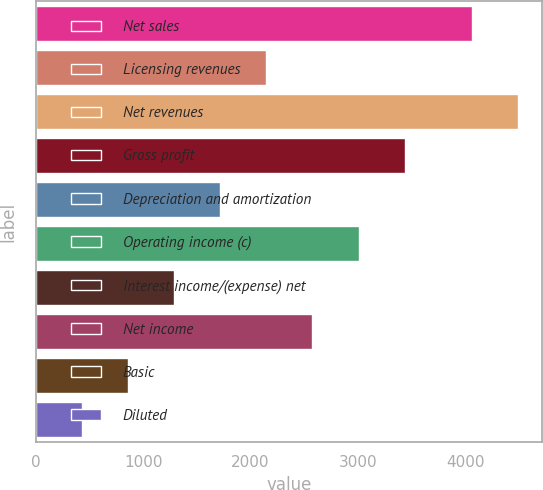Convert chart to OTSL. <chart><loc_0><loc_0><loc_500><loc_500><bar_chart><fcel>Net sales<fcel>Licensing revenues<fcel>Net revenues<fcel>Gross profit<fcel>Depreciation and amortization<fcel>Operating income (c)<fcel>Interest income/(expense) net<fcel>Net income<fcel>Basic<fcel>Diluted<nl><fcel>4059.1<fcel>2147.8<fcel>4488.62<fcel>3436.36<fcel>1718.28<fcel>3006.84<fcel>1288.76<fcel>2577.32<fcel>859.24<fcel>429.72<nl></chart> 